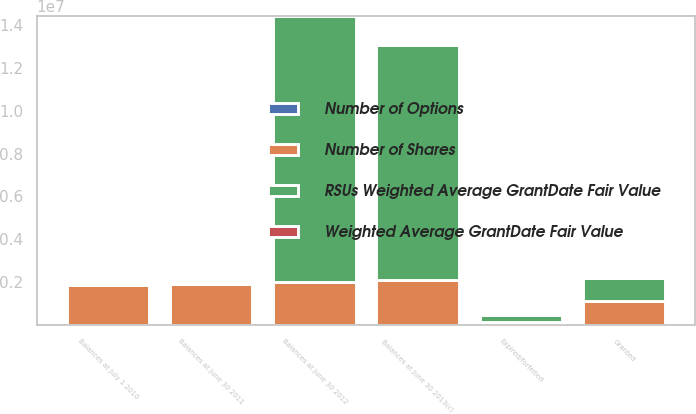Convert chart. <chart><loc_0><loc_0><loc_500><loc_500><stacked_bar_chart><ecel><fcel>Balances at July 1 2010<fcel>Balances at June 30 2011<fcel>Granted<fcel>Expired/forfeited<fcel>Balances at June 30 2012<fcel>Balances at June 30 2013(c)<nl><fcel>RSUs Weighted Average GrantDate Fair Value<fcel>22.2<fcel>22.2<fcel>1.05754e+06<fcel>299163<fcel>1.23815e+07<fcel>1.09855e+07<nl><fcel>Number of Options<fcel>19.33<fcel>18.94<fcel>24.01<fcel>20.03<fcel>19.42<fcel>20.39<nl><fcel>Number of Shares<fcel>1.88417e+06<fcel>1.932e+06<fcel>1.14262e+06<fcel>161158<fcel>2.02557e+06<fcel>2.08683e+06<nl><fcel>Weighted Average GrantDate Fair Value<fcel>16.52<fcel>20.19<fcel>18.37<fcel>19.91<fcel>19.61<fcel>19.65<nl></chart> 